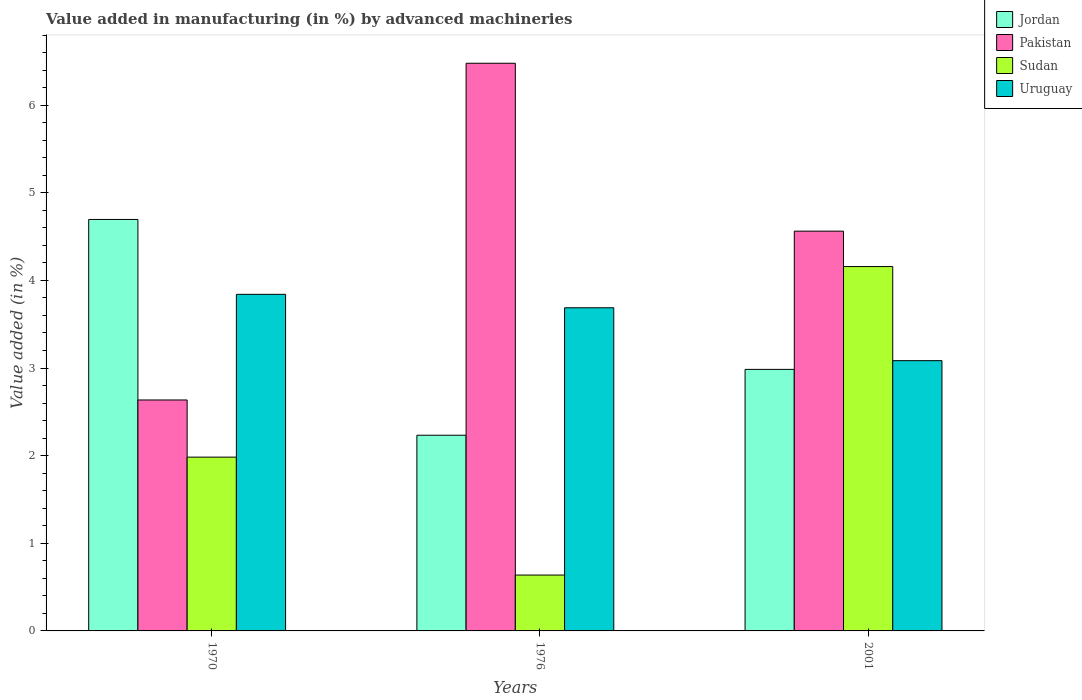How many groups of bars are there?
Give a very brief answer. 3. Are the number of bars per tick equal to the number of legend labels?
Make the answer very short. Yes. How many bars are there on the 1st tick from the right?
Your response must be concise. 4. What is the percentage of value added in manufacturing by advanced machineries in Pakistan in 2001?
Keep it short and to the point. 4.56. Across all years, what is the maximum percentage of value added in manufacturing by advanced machineries in Jordan?
Offer a terse response. 4.7. Across all years, what is the minimum percentage of value added in manufacturing by advanced machineries in Sudan?
Give a very brief answer. 0.64. In which year was the percentage of value added in manufacturing by advanced machineries in Uruguay maximum?
Your response must be concise. 1970. In which year was the percentage of value added in manufacturing by advanced machineries in Sudan minimum?
Provide a short and direct response. 1976. What is the total percentage of value added in manufacturing by advanced machineries in Sudan in the graph?
Offer a very short reply. 6.78. What is the difference between the percentage of value added in manufacturing by advanced machineries in Pakistan in 1976 and that in 2001?
Offer a terse response. 1.92. What is the difference between the percentage of value added in manufacturing by advanced machineries in Pakistan in 1976 and the percentage of value added in manufacturing by advanced machineries in Sudan in 2001?
Offer a very short reply. 2.32. What is the average percentage of value added in manufacturing by advanced machineries in Jordan per year?
Your answer should be very brief. 3.3. In the year 1970, what is the difference between the percentage of value added in manufacturing by advanced machineries in Pakistan and percentage of value added in manufacturing by advanced machineries in Uruguay?
Keep it short and to the point. -1.21. What is the ratio of the percentage of value added in manufacturing by advanced machineries in Jordan in 1976 to that in 2001?
Provide a short and direct response. 0.75. What is the difference between the highest and the second highest percentage of value added in manufacturing by advanced machineries in Sudan?
Offer a very short reply. 2.17. What is the difference between the highest and the lowest percentage of value added in manufacturing by advanced machineries in Jordan?
Your answer should be very brief. 2.46. What does the 4th bar from the right in 2001 represents?
Ensure brevity in your answer.  Jordan. Is it the case that in every year, the sum of the percentage of value added in manufacturing by advanced machineries in Pakistan and percentage of value added in manufacturing by advanced machineries in Uruguay is greater than the percentage of value added in manufacturing by advanced machineries in Jordan?
Give a very brief answer. Yes. Are all the bars in the graph horizontal?
Your answer should be compact. No. What is the difference between two consecutive major ticks on the Y-axis?
Your response must be concise. 1. Where does the legend appear in the graph?
Offer a very short reply. Top right. How many legend labels are there?
Keep it short and to the point. 4. How are the legend labels stacked?
Provide a succinct answer. Vertical. What is the title of the graph?
Offer a very short reply. Value added in manufacturing (in %) by advanced machineries. What is the label or title of the Y-axis?
Provide a succinct answer. Value added (in %). What is the Value added (in %) in Jordan in 1970?
Make the answer very short. 4.7. What is the Value added (in %) in Pakistan in 1970?
Offer a very short reply. 2.64. What is the Value added (in %) in Sudan in 1970?
Your answer should be very brief. 1.98. What is the Value added (in %) of Uruguay in 1970?
Provide a succinct answer. 3.84. What is the Value added (in %) in Jordan in 1976?
Provide a succinct answer. 2.23. What is the Value added (in %) in Pakistan in 1976?
Ensure brevity in your answer.  6.48. What is the Value added (in %) of Sudan in 1976?
Your response must be concise. 0.64. What is the Value added (in %) of Uruguay in 1976?
Make the answer very short. 3.69. What is the Value added (in %) of Jordan in 2001?
Your answer should be compact. 2.98. What is the Value added (in %) of Pakistan in 2001?
Make the answer very short. 4.56. What is the Value added (in %) in Sudan in 2001?
Provide a short and direct response. 4.16. What is the Value added (in %) of Uruguay in 2001?
Offer a terse response. 3.08. Across all years, what is the maximum Value added (in %) of Jordan?
Your answer should be compact. 4.7. Across all years, what is the maximum Value added (in %) of Pakistan?
Make the answer very short. 6.48. Across all years, what is the maximum Value added (in %) in Sudan?
Make the answer very short. 4.16. Across all years, what is the maximum Value added (in %) of Uruguay?
Provide a short and direct response. 3.84. Across all years, what is the minimum Value added (in %) in Jordan?
Ensure brevity in your answer.  2.23. Across all years, what is the minimum Value added (in %) of Pakistan?
Your response must be concise. 2.64. Across all years, what is the minimum Value added (in %) in Sudan?
Your answer should be very brief. 0.64. Across all years, what is the minimum Value added (in %) in Uruguay?
Offer a very short reply. 3.08. What is the total Value added (in %) in Jordan in the graph?
Your answer should be compact. 9.91. What is the total Value added (in %) in Pakistan in the graph?
Make the answer very short. 13.67. What is the total Value added (in %) in Sudan in the graph?
Your response must be concise. 6.78. What is the total Value added (in %) of Uruguay in the graph?
Make the answer very short. 10.61. What is the difference between the Value added (in %) in Jordan in 1970 and that in 1976?
Make the answer very short. 2.46. What is the difference between the Value added (in %) of Pakistan in 1970 and that in 1976?
Provide a succinct answer. -3.84. What is the difference between the Value added (in %) in Sudan in 1970 and that in 1976?
Make the answer very short. 1.35. What is the difference between the Value added (in %) of Uruguay in 1970 and that in 1976?
Offer a terse response. 0.15. What is the difference between the Value added (in %) of Jordan in 1970 and that in 2001?
Make the answer very short. 1.71. What is the difference between the Value added (in %) of Pakistan in 1970 and that in 2001?
Provide a succinct answer. -1.93. What is the difference between the Value added (in %) of Sudan in 1970 and that in 2001?
Provide a short and direct response. -2.17. What is the difference between the Value added (in %) of Uruguay in 1970 and that in 2001?
Your response must be concise. 0.76. What is the difference between the Value added (in %) in Jordan in 1976 and that in 2001?
Offer a very short reply. -0.75. What is the difference between the Value added (in %) in Pakistan in 1976 and that in 2001?
Your answer should be very brief. 1.92. What is the difference between the Value added (in %) in Sudan in 1976 and that in 2001?
Your answer should be very brief. -3.52. What is the difference between the Value added (in %) of Uruguay in 1976 and that in 2001?
Make the answer very short. 0.6. What is the difference between the Value added (in %) in Jordan in 1970 and the Value added (in %) in Pakistan in 1976?
Offer a very short reply. -1.78. What is the difference between the Value added (in %) in Jordan in 1970 and the Value added (in %) in Sudan in 1976?
Your response must be concise. 4.06. What is the difference between the Value added (in %) of Pakistan in 1970 and the Value added (in %) of Sudan in 1976?
Offer a terse response. 2. What is the difference between the Value added (in %) of Pakistan in 1970 and the Value added (in %) of Uruguay in 1976?
Your answer should be very brief. -1.05. What is the difference between the Value added (in %) of Sudan in 1970 and the Value added (in %) of Uruguay in 1976?
Your response must be concise. -1.7. What is the difference between the Value added (in %) of Jordan in 1970 and the Value added (in %) of Pakistan in 2001?
Offer a very short reply. 0.13. What is the difference between the Value added (in %) of Jordan in 1970 and the Value added (in %) of Sudan in 2001?
Ensure brevity in your answer.  0.54. What is the difference between the Value added (in %) of Jordan in 1970 and the Value added (in %) of Uruguay in 2001?
Your answer should be compact. 1.61. What is the difference between the Value added (in %) of Pakistan in 1970 and the Value added (in %) of Sudan in 2001?
Offer a very short reply. -1.52. What is the difference between the Value added (in %) of Pakistan in 1970 and the Value added (in %) of Uruguay in 2001?
Provide a short and direct response. -0.45. What is the difference between the Value added (in %) of Sudan in 1970 and the Value added (in %) of Uruguay in 2001?
Provide a succinct answer. -1.1. What is the difference between the Value added (in %) of Jordan in 1976 and the Value added (in %) of Pakistan in 2001?
Ensure brevity in your answer.  -2.33. What is the difference between the Value added (in %) in Jordan in 1976 and the Value added (in %) in Sudan in 2001?
Provide a succinct answer. -1.92. What is the difference between the Value added (in %) in Jordan in 1976 and the Value added (in %) in Uruguay in 2001?
Your answer should be very brief. -0.85. What is the difference between the Value added (in %) of Pakistan in 1976 and the Value added (in %) of Sudan in 2001?
Your answer should be compact. 2.32. What is the difference between the Value added (in %) of Pakistan in 1976 and the Value added (in %) of Uruguay in 2001?
Provide a succinct answer. 3.39. What is the difference between the Value added (in %) in Sudan in 1976 and the Value added (in %) in Uruguay in 2001?
Ensure brevity in your answer.  -2.45. What is the average Value added (in %) in Jordan per year?
Your answer should be compact. 3.3. What is the average Value added (in %) of Pakistan per year?
Offer a terse response. 4.56. What is the average Value added (in %) in Sudan per year?
Offer a terse response. 2.26. What is the average Value added (in %) in Uruguay per year?
Offer a very short reply. 3.54. In the year 1970, what is the difference between the Value added (in %) in Jordan and Value added (in %) in Pakistan?
Offer a terse response. 2.06. In the year 1970, what is the difference between the Value added (in %) of Jordan and Value added (in %) of Sudan?
Make the answer very short. 2.71. In the year 1970, what is the difference between the Value added (in %) in Jordan and Value added (in %) in Uruguay?
Offer a terse response. 0.85. In the year 1970, what is the difference between the Value added (in %) in Pakistan and Value added (in %) in Sudan?
Your response must be concise. 0.65. In the year 1970, what is the difference between the Value added (in %) in Pakistan and Value added (in %) in Uruguay?
Offer a terse response. -1.21. In the year 1970, what is the difference between the Value added (in %) of Sudan and Value added (in %) of Uruguay?
Provide a succinct answer. -1.86. In the year 1976, what is the difference between the Value added (in %) of Jordan and Value added (in %) of Pakistan?
Give a very brief answer. -4.24. In the year 1976, what is the difference between the Value added (in %) in Jordan and Value added (in %) in Sudan?
Offer a very short reply. 1.6. In the year 1976, what is the difference between the Value added (in %) of Jordan and Value added (in %) of Uruguay?
Offer a very short reply. -1.45. In the year 1976, what is the difference between the Value added (in %) in Pakistan and Value added (in %) in Sudan?
Ensure brevity in your answer.  5.84. In the year 1976, what is the difference between the Value added (in %) in Pakistan and Value added (in %) in Uruguay?
Your answer should be very brief. 2.79. In the year 1976, what is the difference between the Value added (in %) in Sudan and Value added (in %) in Uruguay?
Your answer should be compact. -3.05. In the year 2001, what is the difference between the Value added (in %) in Jordan and Value added (in %) in Pakistan?
Offer a very short reply. -1.58. In the year 2001, what is the difference between the Value added (in %) of Jordan and Value added (in %) of Sudan?
Ensure brevity in your answer.  -1.17. In the year 2001, what is the difference between the Value added (in %) in Jordan and Value added (in %) in Uruguay?
Provide a succinct answer. -0.1. In the year 2001, what is the difference between the Value added (in %) in Pakistan and Value added (in %) in Sudan?
Provide a succinct answer. 0.4. In the year 2001, what is the difference between the Value added (in %) of Pakistan and Value added (in %) of Uruguay?
Provide a succinct answer. 1.48. In the year 2001, what is the difference between the Value added (in %) of Sudan and Value added (in %) of Uruguay?
Keep it short and to the point. 1.07. What is the ratio of the Value added (in %) of Jordan in 1970 to that in 1976?
Your answer should be very brief. 2.1. What is the ratio of the Value added (in %) in Pakistan in 1970 to that in 1976?
Your response must be concise. 0.41. What is the ratio of the Value added (in %) in Sudan in 1970 to that in 1976?
Your answer should be very brief. 3.11. What is the ratio of the Value added (in %) in Uruguay in 1970 to that in 1976?
Provide a short and direct response. 1.04. What is the ratio of the Value added (in %) of Jordan in 1970 to that in 2001?
Offer a terse response. 1.57. What is the ratio of the Value added (in %) in Pakistan in 1970 to that in 2001?
Keep it short and to the point. 0.58. What is the ratio of the Value added (in %) in Sudan in 1970 to that in 2001?
Your answer should be compact. 0.48. What is the ratio of the Value added (in %) of Uruguay in 1970 to that in 2001?
Provide a short and direct response. 1.25. What is the ratio of the Value added (in %) in Jordan in 1976 to that in 2001?
Your answer should be compact. 0.75. What is the ratio of the Value added (in %) in Pakistan in 1976 to that in 2001?
Your response must be concise. 1.42. What is the ratio of the Value added (in %) of Sudan in 1976 to that in 2001?
Make the answer very short. 0.15. What is the ratio of the Value added (in %) of Uruguay in 1976 to that in 2001?
Provide a succinct answer. 1.2. What is the difference between the highest and the second highest Value added (in %) of Jordan?
Make the answer very short. 1.71. What is the difference between the highest and the second highest Value added (in %) in Pakistan?
Make the answer very short. 1.92. What is the difference between the highest and the second highest Value added (in %) in Sudan?
Provide a succinct answer. 2.17. What is the difference between the highest and the second highest Value added (in %) in Uruguay?
Make the answer very short. 0.15. What is the difference between the highest and the lowest Value added (in %) of Jordan?
Make the answer very short. 2.46. What is the difference between the highest and the lowest Value added (in %) in Pakistan?
Provide a short and direct response. 3.84. What is the difference between the highest and the lowest Value added (in %) in Sudan?
Offer a terse response. 3.52. What is the difference between the highest and the lowest Value added (in %) in Uruguay?
Offer a very short reply. 0.76. 